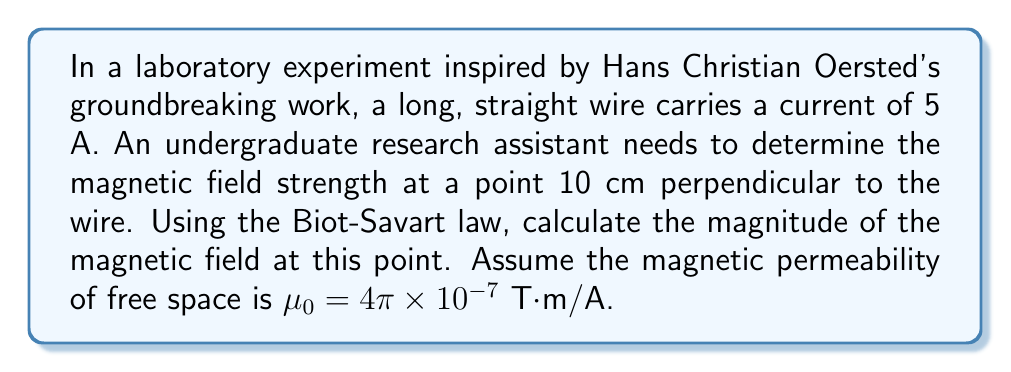Show me your answer to this math problem. Let's approach this step-by-step using the Biot-Savart law:

1) The Biot-Savart law for a long, straight wire is given by:

   $$B = \frac{\mu_0 I}{2\pi r}$$

   Where:
   $B$ is the magnetic field strength
   $\mu_0$ is the magnetic permeability of free space
   $I$ is the current in the wire
   $r$ is the perpendicular distance from the wire to the point

2) We're given:
   $I = 5$ A
   $r = 10$ cm $= 0.1$ m
   $\mu_0 = 4\pi \times 10^{-7}$ T·m/A

3) Let's substitute these values into the equation:

   $$B = \frac{(4\pi \times 10^{-7})(5)}{2\pi(0.1)}$$

4) Simplify:
   
   $$B = \frac{20\pi \times 10^{-7}}{2\pi(0.1)} = \frac{10 \times 10^{-7}}{0.1} = 10 \times 10^{-6}$$

5) Therefore:

   $$B = 1 \times 10^{-5}$$ T

This result beautifully demonstrates the inverse relationship between magnetic field strength and distance from the wire, a concept that would have fascinated early pioneers in electromagnetism like Oersted and Ampère.
Answer: $1 \times 10^{-5}$ T 